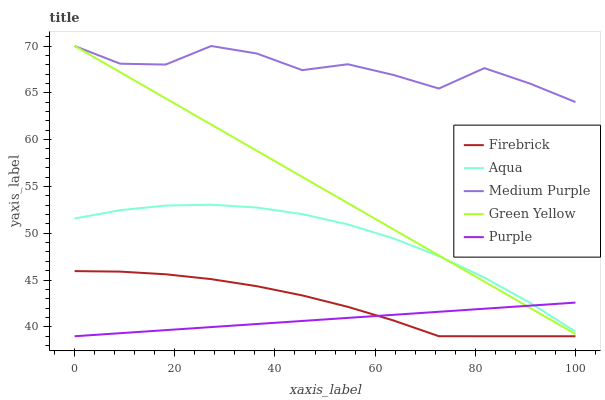Does Purple have the minimum area under the curve?
Answer yes or no. Yes. Does Medium Purple have the maximum area under the curve?
Answer yes or no. Yes. Does Firebrick have the minimum area under the curve?
Answer yes or no. No. Does Firebrick have the maximum area under the curve?
Answer yes or no. No. Is Purple the smoothest?
Answer yes or no. Yes. Is Medium Purple the roughest?
Answer yes or no. Yes. Is Firebrick the smoothest?
Answer yes or no. No. Is Firebrick the roughest?
Answer yes or no. No. Does Green Yellow have the lowest value?
Answer yes or no. No. Does Firebrick have the highest value?
Answer yes or no. No. Is Firebrick less than Medium Purple?
Answer yes or no. Yes. Is Medium Purple greater than Purple?
Answer yes or no. Yes. Does Firebrick intersect Medium Purple?
Answer yes or no. No. 